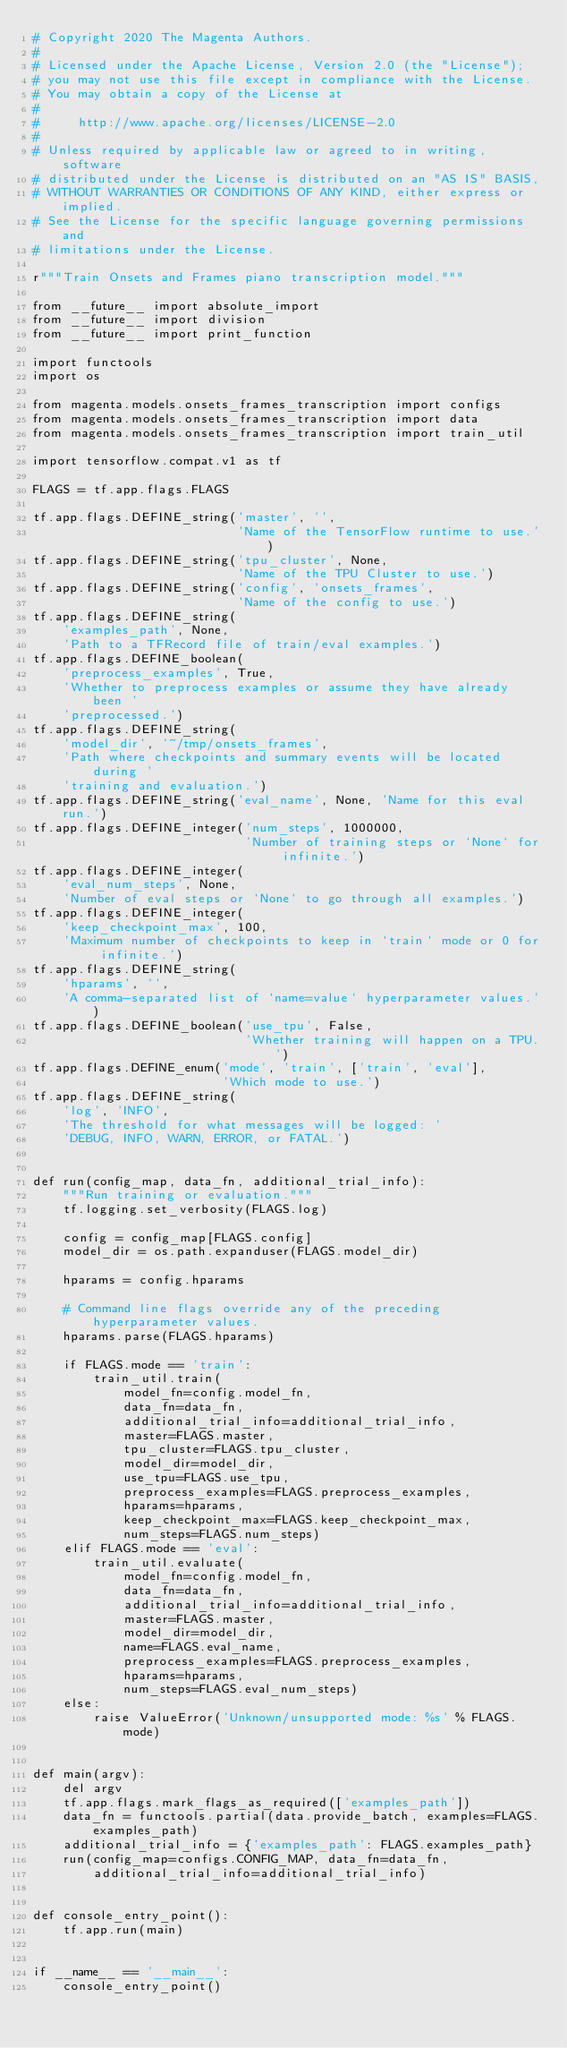Convert code to text. <code><loc_0><loc_0><loc_500><loc_500><_Python_># Copyright 2020 The Magenta Authors.
#
# Licensed under the Apache License, Version 2.0 (the "License");
# you may not use this file except in compliance with the License.
# You may obtain a copy of the License at
#
#     http://www.apache.org/licenses/LICENSE-2.0
#
# Unless required by applicable law or agreed to in writing, software
# distributed under the License is distributed on an "AS IS" BASIS,
# WITHOUT WARRANTIES OR CONDITIONS OF ANY KIND, either express or implied.
# See the License for the specific language governing permissions and
# limitations under the License.

r"""Train Onsets and Frames piano transcription model."""

from __future__ import absolute_import
from __future__ import division
from __future__ import print_function

import functools
import os

from magenta.models.onsets_frames_transcription import configs
from magenta.models.onsets_frames_transcription import data
from magenta.models.onsets_frames_transcription import train_util

import tensorflow.compat.v1 as tf

FLAGS = tf.app.flags.FLAGS

tf.app.flags.DEFINE_string('master', '',
                           'Name of the TensorFlow runtime to use.')
tf.app.flags.DEFINE_string('tpu_cluster', None,
                           'Name of the TPU Cluster to use.')
tf.app.flags.DEFINE_string('config', 'onsets_frames',
                           'Name of the config to use.')
tf.app.flags.DEFINE_string(
    'examples_path', None,
    'Path to a TFRecord file of train/eval examples.')
tf.app.flags.DEFINE_boolean(
    'preprocess_examples', True,
    'Whether to preprocess examples or assume they have already been '
    'preprocessed.')
tf.app.flags.DEFINE_string(
    'model_dir', '~/tmp/onsets_frames',
    'Path where checkpoints and summary events will be located during '
    'training and evaluation.')
tf.app.flags.DEFINE_string('eval_name', None, 'Name for this eval run.')
tf.app.flags.DEFINE_integer('num_steps', 1000000,
                            'Number of training steps or `None` for infinite.')
tf.app.flags.DEFINE_integer(
    'eval_num_steps', None,
    'Number of eval steps or `None` to go through all examples.')
tf.app.flags.DEFINE_integer(
    'keep_checkpoint_max', 100,
    'Maximum number of checkpoints to keep in `train` mode or 0 for infinite.')
tf.app.flags.DEFINE_string(
    'hparams', '',
    'A comma-separated list of `name=value` hyperparameter values.')
tf.app.flags.DEFINE_boolean('use_tpu', False,
                            'Whether training will happen on a TPU.')
tf.app.flags.DEFINE_enum('mode', 'train', ['train', 'eval'],
                         'Which mode to use.')
tf.app.flags.DEFINE_string(
    'log', 'INFO',
    'The threshold for what messages will be logged: '
    'DEBUG, INFO, WARN, ERROR, or FATAL.')


def run(config_map, data_fn, additional_trial_info):
    """Run training or evaluation."""
    tf.logging.set_verbosity(FLAGS.log)

    config = config_map[FLAGS.config]
    model_dir = os.path.expanduser(FLAGS.model_dir)

    hparams = config.hparams

    # Command line flags override any of the preceding hyperparameter values.
    hparams.parse(FLAGS.hparams)

    if FLAGS.mode == 'train':
        train_util.train(
            model_fn=config.model_fn,
            data_fn=data_fn,
            additional_trial_info=additional_trial_info,
            master=FLAGS.master,
            tpu_cluster=FLAGS.tpu_cluster,
            model_dir=model_dir,
            use_tpu=FLAGS.use_tpu,
            preprocess_examples=FLAGS.preprocess_examples,
            hparams=hparams,
            keep_checkpoint_max=FLAGS.keep_checkpoint_max,
            num_steps=FLAGS.num_steps)
    elif FLAGS.mode == 'eval':
        train_util.evaluate(
            model_fn=config.model_fn,
            data_fn=data_fn,
            additional_trial_info=additional_trial_info,
            master=FLAGS.master,
            model_dir=model_dir,
            name=FLAGS.eval_name,
            preprocess_examples=FLAGS.preprocess_examples,
            hparams=hparams,
            num_steps=FLAGS.eval_num_steps)
    else:
        raise ValueError('Unknown/unsupported mode: %s' % FLAGS.mode)


def main(argv):
    del argv
    tf.app.flags.mark_flags_as_required(['examples_path'])
    data_fn = functools.partial(data.provide_batch, examples=FLAGS.examples_path)
    additional_trial_info = {'examples_path': FLAGS.examples_path}
    run(config_map=configs.CONFIG_MAP, data_fn=data_fn,
        additional_trial_info=additional_trial_info)


def console_entry_point():
    tf.app.run(main)


if __name__ == '__main__':
    console_entry_point()
</code> 